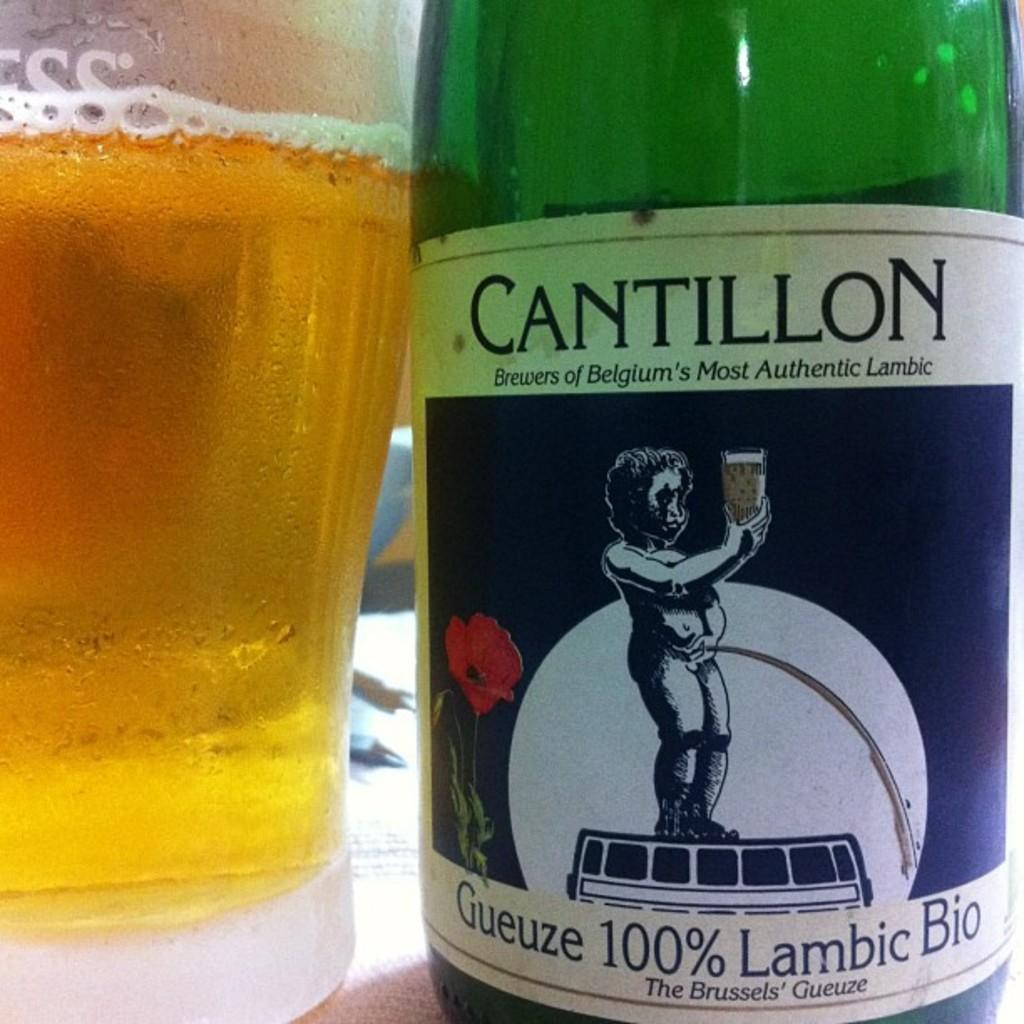<image>
Relay a brief, clear account of the picture shown. a green glass bottle of cantillon belgium beer 